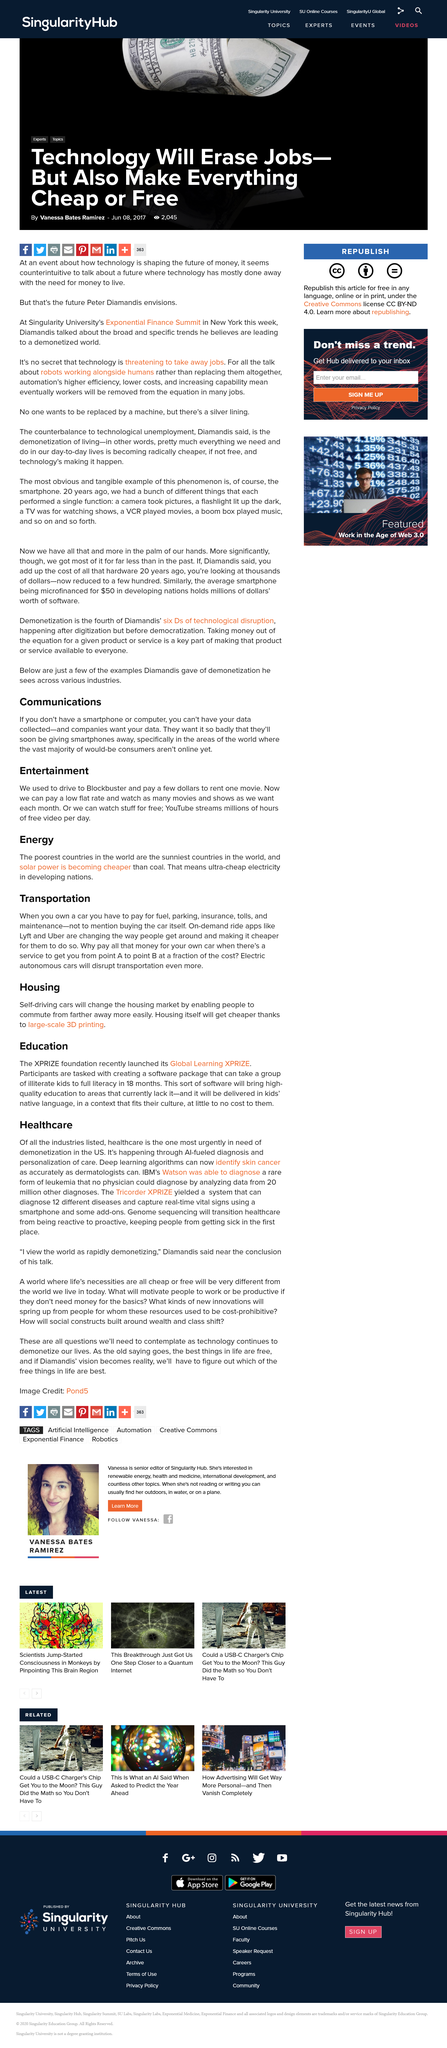Specify some key components in this picture. On-demand ride apps are revolutionizing the way people travel, providing a more affordable and convenient alternative to traditional modes of transportation. By using advanced technology and real-time data, these apps are transforming the transportation industry and changing the way people move around their cities. IBM's Watson used data from a pool of 20 million other diagnoses to accurately diagnose a rare form of leukemia in a patient. Yes, AI diagnostic tools can identify skin cancer as accurately as a dermatologist, thanks to the use of deep learning algorithms. When owning a car, one is required to pay for fuel, parking, insurance, tolls, and maintenance costs. On-demand ride apps such as Lyft and Uber have become increasingly popular in recent years. 